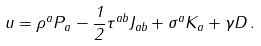Convert formula to latex. <formula><loc_0><loc_0><loc_500><loc_500>u = \rho ^ { a } P _ { a } - \frac { 1 } { 2 } \tau ^ { a b } J _ { a b } + \sigma ^ { a } K _ { a } + \gamma D \, .</formula> 